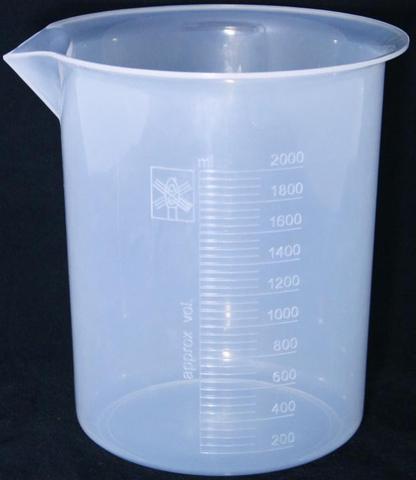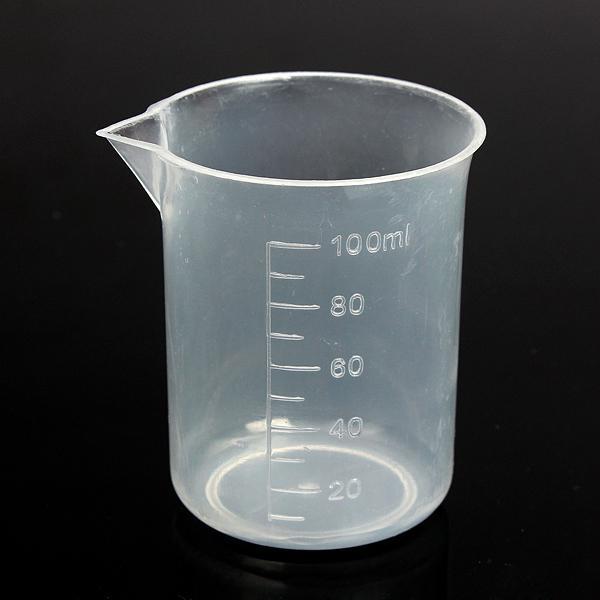The first image is the image on the left, the second image is the image on the right. For the images displayed, is the sentence "The measuring cup in one of the pictures has black writing and markings on it." factually correct? Answer yes or no. No. The first image is the image on the left, the second image is the image on the right. For the images displayed, is the sentence "The left and right image contains the same number of beakers with at least one with a handle." factually correct? Answer yes or no. No. 